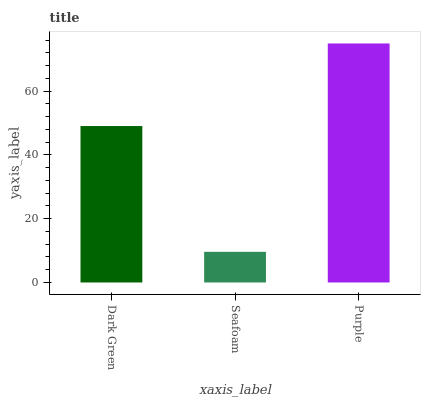Is Seafoam the minimum?
Answer yes or no. Yes. Is Purple the maximum?
Answer yes or no. Yes. Is Purple the minimum?
Answer yes or no. No. Is Seafoam the maximum?
Answer yes or no. No. Is Purple greater than Seafoam?
Answer yes or no. Yes. Is Seafoam less than Purple?
Answer yes or no. Yes. Is Seafoam greater than Purple?
Answer yes or no. No. Is Purple less than Seafoam?
Answer yes or no. No. Is Dark Green the high median?
Answer yes or no. Yes. Is Dark Green the low median?
Answer yes or no. Yes. Is Seafoam the high median?
Answer yes or no. No. Is Seafoam the low median?
Answer yes or no. No. 